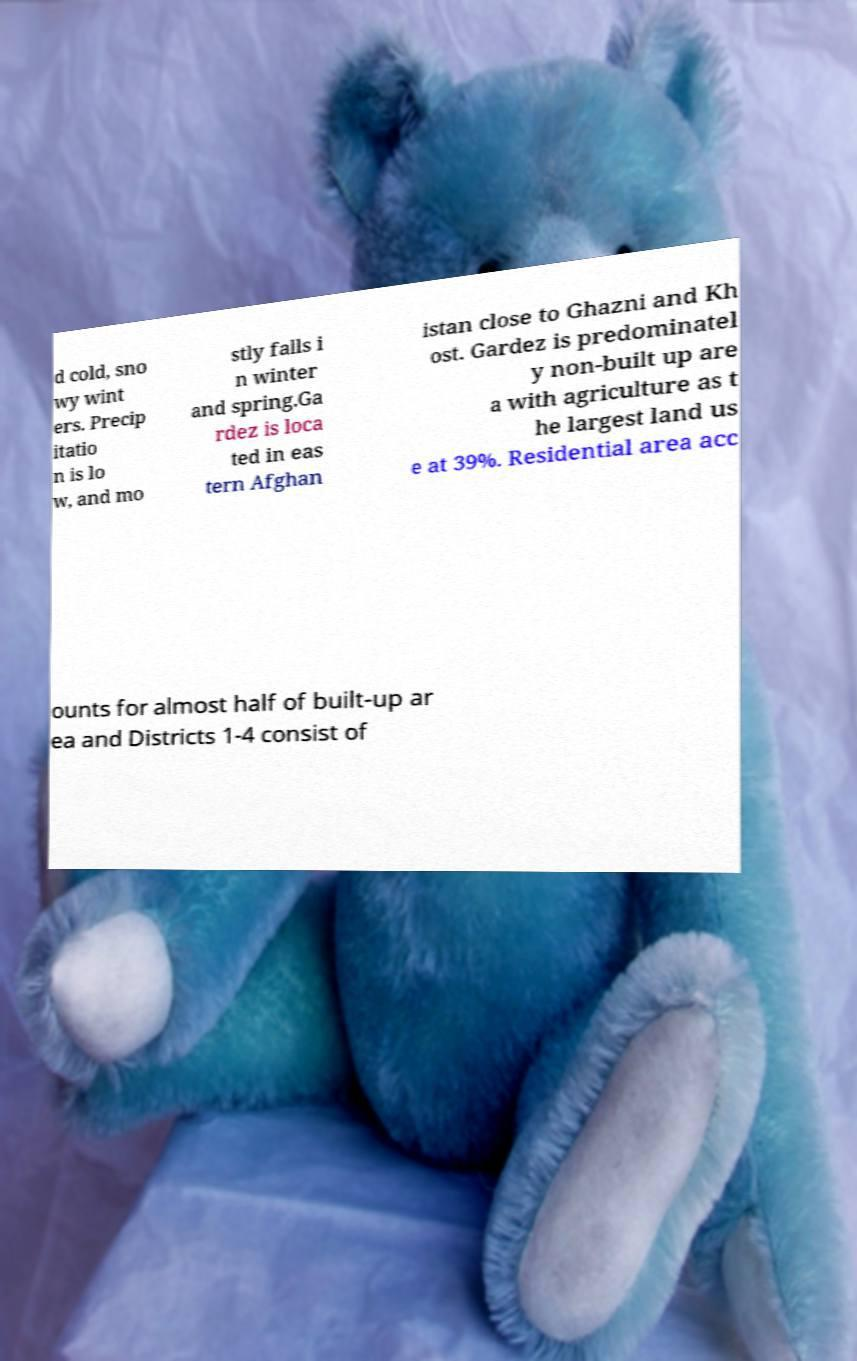Please identify and transcribe the text found in this image. d cold, sno wy wint ers. Precip itatio n is lo w, and mo stly falls i n winter and spring.Ga rdez is loca ted in eas tern Afghan istan close to Ghazni and Kh ost. Gardez is predominatel y non-built up are a with agriculture as t he largest land us e at 39%. Residential area acc ounts for almost half of built-up ar ea and Districts 1-4 consist of 